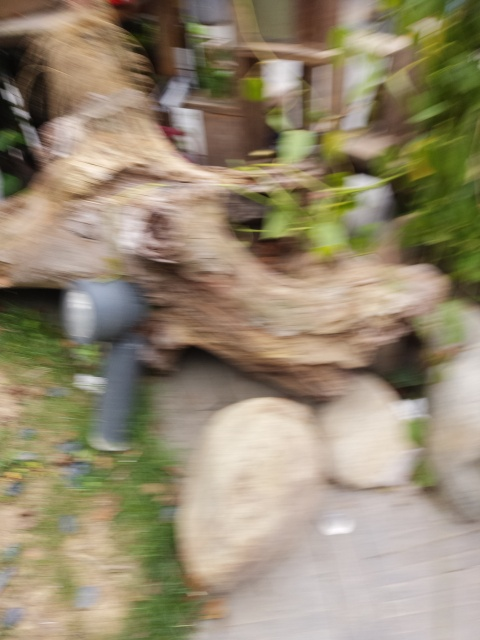Despite the blur, can you make out any objects or shapes that give a clue about where this might be? Despite the blurriness, we can identify the shape of a log, some rocks, and patches of green that suggest the presence of plants or bushes. These elements hint at an outdoor setting, possibly a garden, park, or a natural area where such objects are commonly found. 